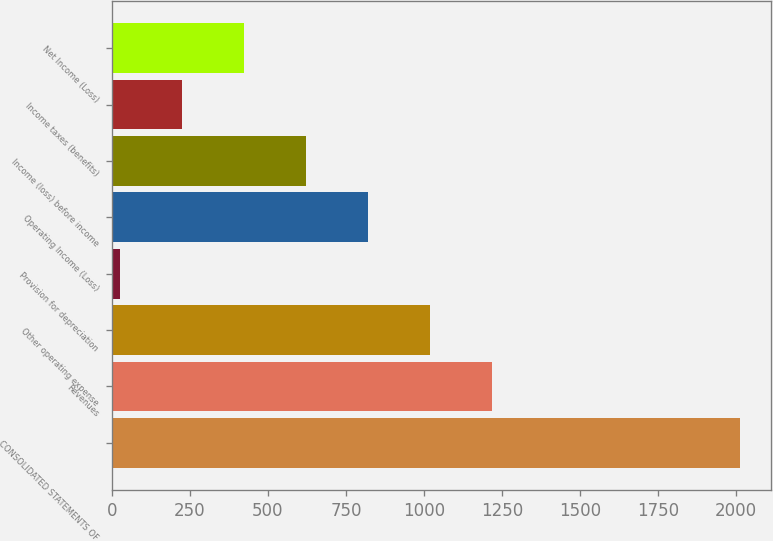<chart> <loc_0><loc_0><loc_500><loc_500><bar_chart><fcel>CONSOLIDATED STATEMENTS OF<fcel>Revenues<fcel>Other operating expense<fcel>Provision for depreciation<fcel>Operating Income (Loss)<fcel>Income (loss) before income<fcel>Income taxes (benefits)<fcel>Net Income (Loss)<nl><fcel>2012<fcel>1217.6<fcel>1019<fcel>26<fcel>820.4<fcel>621.8<fcel>224.6<fcel>423.2<nl></chart> 